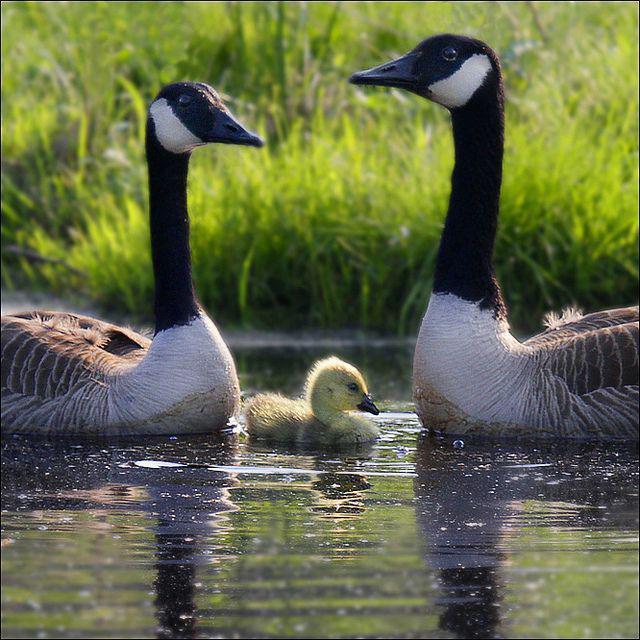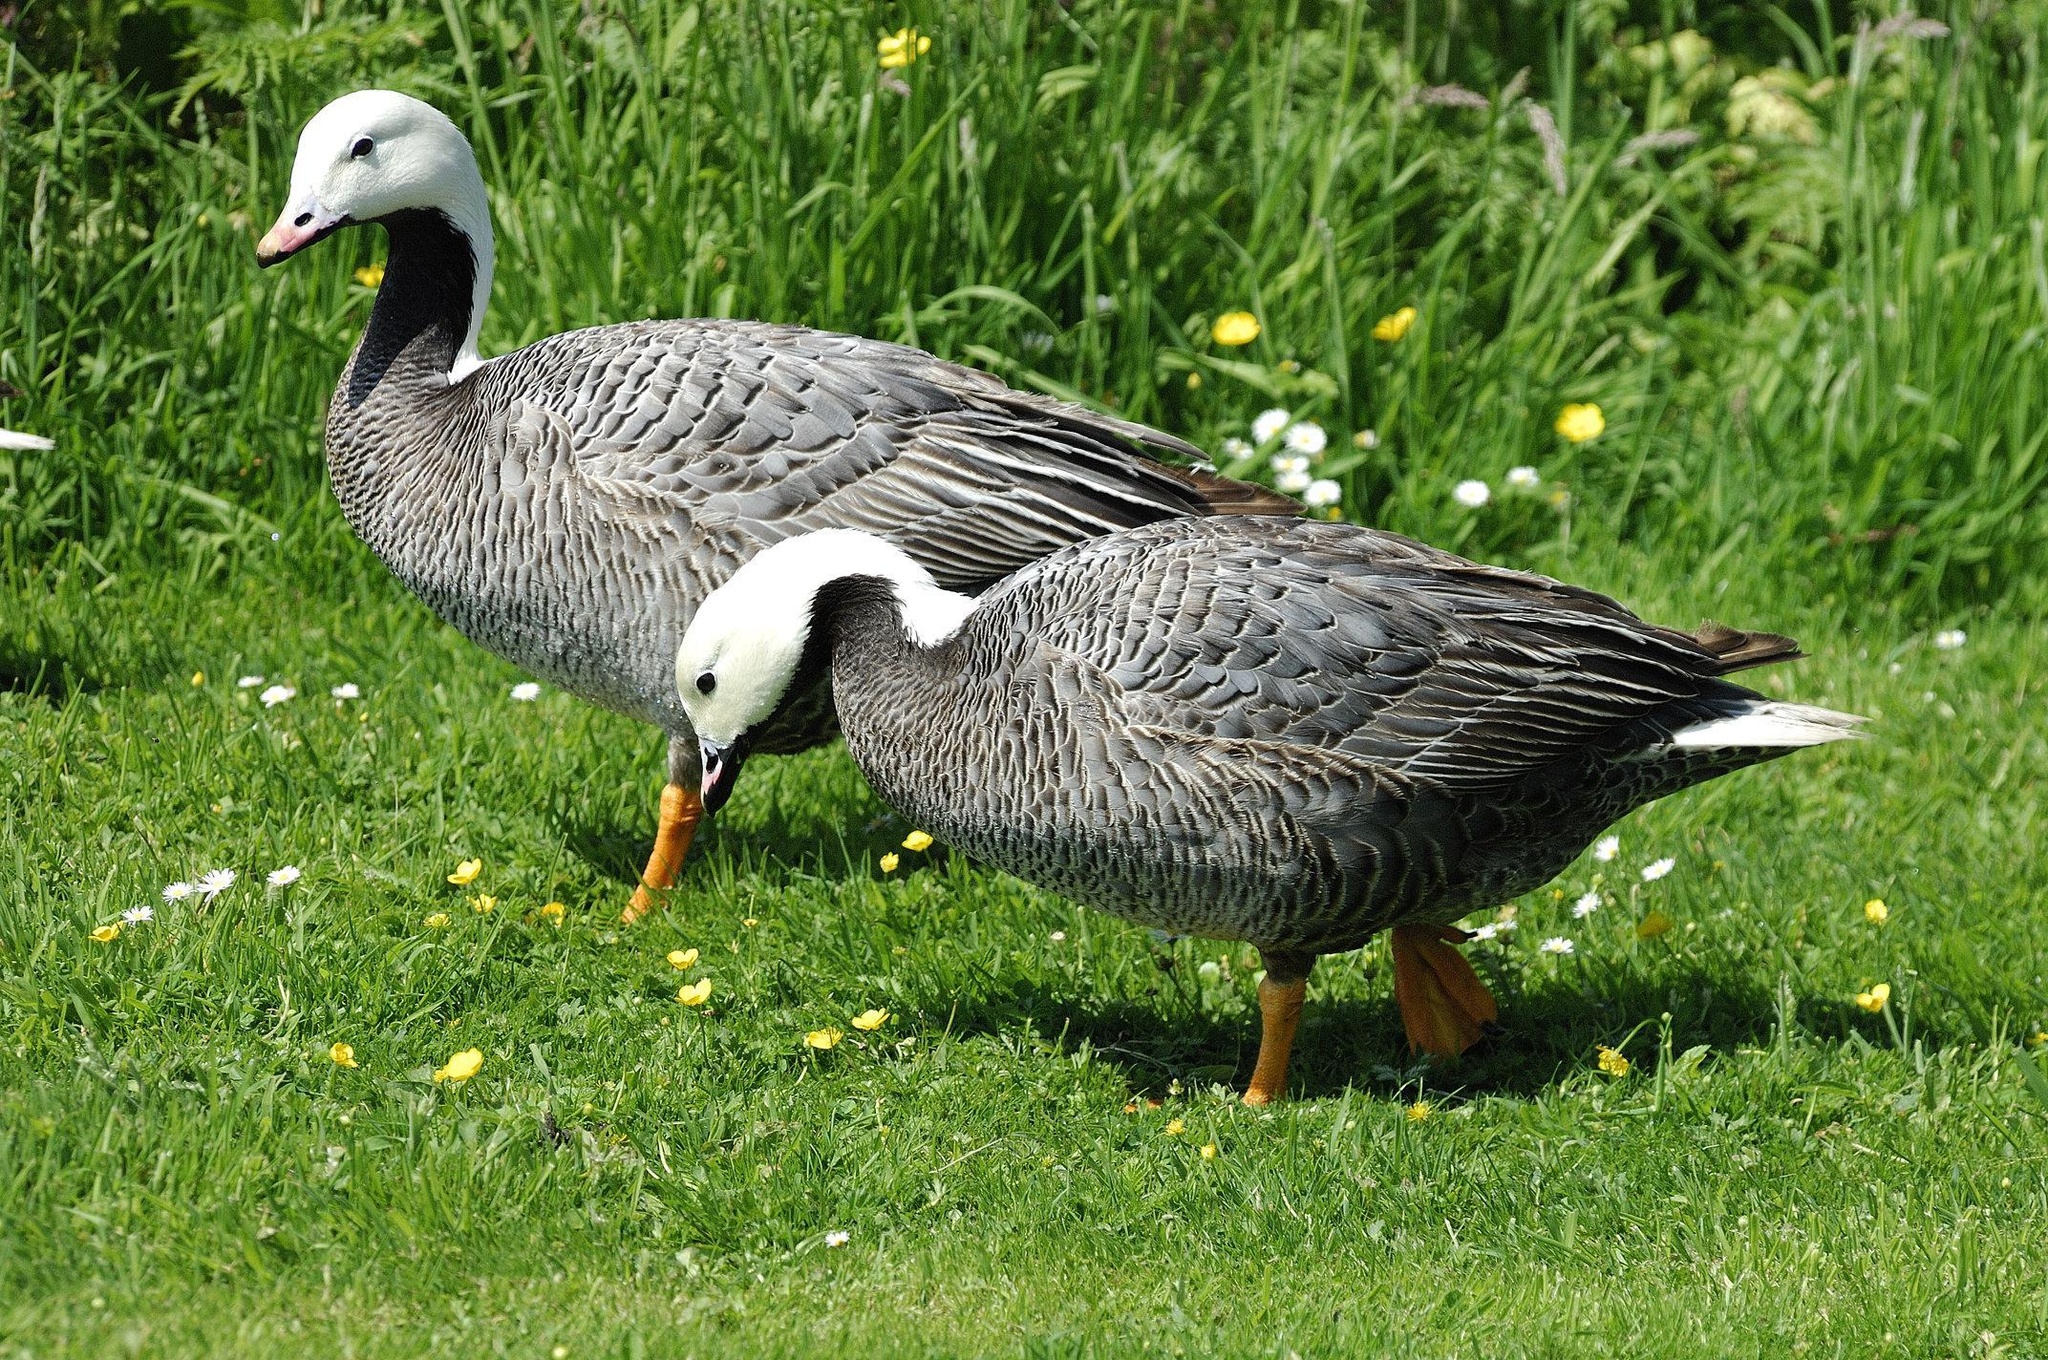The first image is the image on the left, the second image is the image on the right. Given the left and right images, does the statement "there are two ducks in the right image." hold true? Answer yes or no. Yes. The first image is the image on the left, the second image is the image on the right. Examine the images to the left and right. Is the description "An image shows two adult geese on a grassy field with multiple goslings." accurate? Answer yes or no. No. 